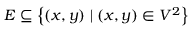Convert formula to latex. <formula><loc_0><loc_0><loc_500><loc_500>E \subseteq \left \{ ( x , y ) | ( x , y ) \in V ^ { 2 } \right \}</formula> 